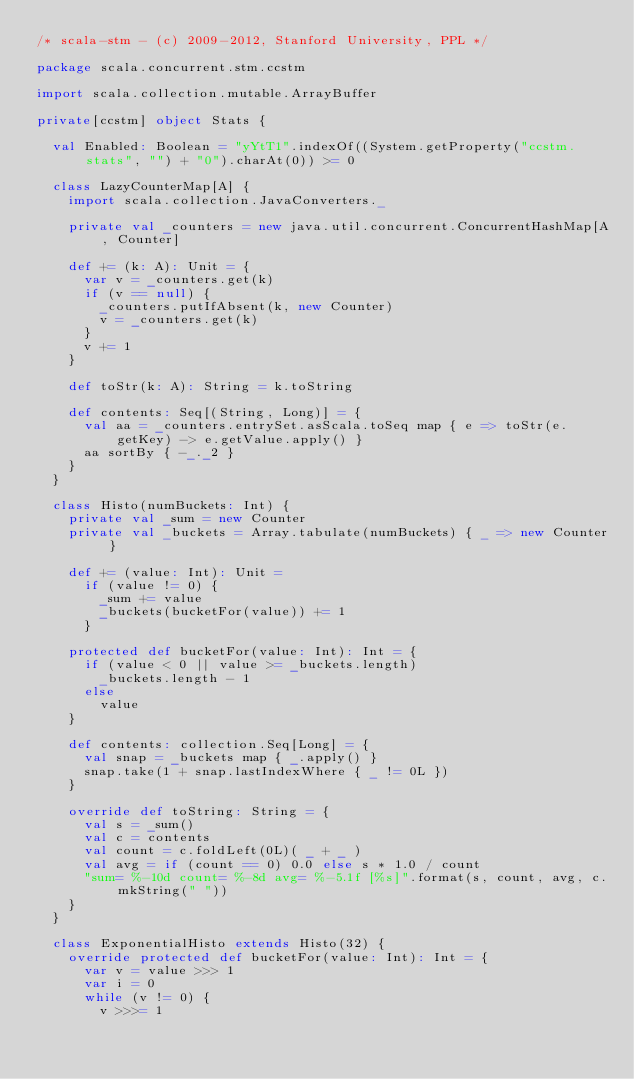<code> <loc_0><loc_0><loc_500><loc_500><_Scala_>/* scala-stm - (c) 2009-2012, Stanford University, PPL */

package scala.concurrent.stm.ccstm

import scala.collection.mutable.ArrayBuffer

private[ccstm] object Stats {

  val Enabled: Boolean = "yYtT1".indexOf((System.getProperty("ccstm.stats", "") + "0").charAt(0)) >= 0

  class LazyCounterMap[A] {
    import scala.collection.JavaConverters._

    private val _counters = new java.util.concurrent.ConcurrentHashMap[A, Counter]

    def += (k: A): Unit = {
      var v = _counters.get(k)
      if (v == null) {
        _counters.putIfAbsent(k, new Counter)
        v = _counters.get(k)
      }
      v += 1
    }

    def toStr(k: A): String = k.toString

    def contents: Seq[(String, Long)] = {
      val aa = _counters.entrySet.asScala.toSeq map { e => toStr(e.getKey) -> e.getValue.apply() }
      aa sortBy { -_._2 }
    }
  }

  class Histo(numBuckets: Int) {
    private val _sum = new Counter
    private val _buckets = Array.tabulate(numBuckets) { _ => new Counter }

    def += (value: Int): Unit =
      if (value != 0) {
        _sum += value
        _buckets(bucketFor(value)) += 1
      }

    protected def bucketFor(value: Int): Int = {
      if (value < 0 || value >= _buckets.length)
        _buckets.length - 1
      else
        value
    }

    def contents: collection.Seq[Long] = {
      val snap = _buckets map { _.apply() }
      snap.take(1 + snap.lastIndexWhere { _ != 0L })
    }

    override def toString: String = {
      val s = _sum()
      val c = contents
      val count = c.foldLeft(0L)( _ + _ )
      val avg = if (count == 0) 0.0 else s * 1.0 / count
      "sum= %-10d count= %-8d avg= %-5.1f [%s]".format(s, count, avg, c.mkString(" "))
    }
  }

  class ExponentialHisto extends Histo(32) {
    override protected def bucketFor(value: Int): Int = {
      var v = value >>> 1
      var i = 0
      while (v != 0) {
        v >>>= 1</code> 